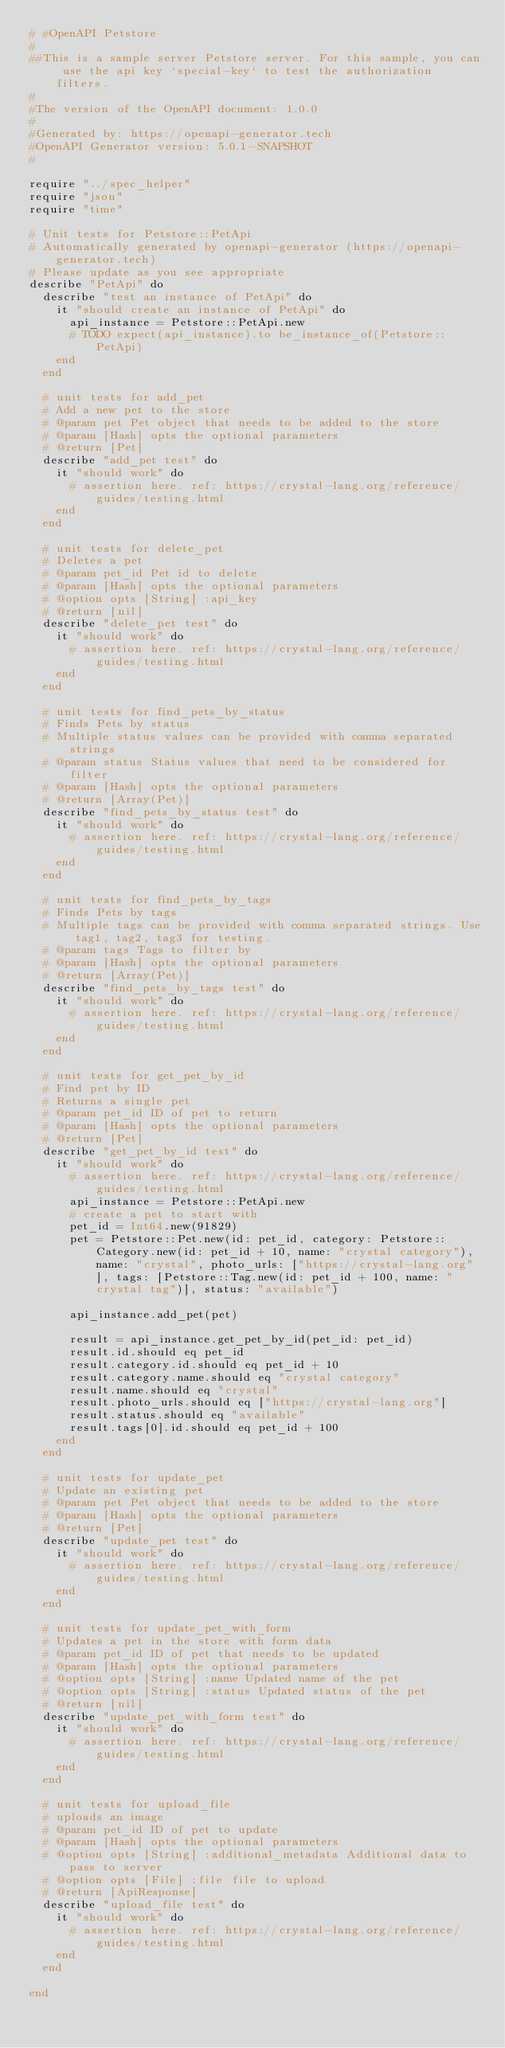Convert code to text. <code><loc_0><loc_0><loc_500><loc_500><_Crystal_># #OpenAPI Petstore
#
##This is a sample server Petstore server. For this sample, you can use the api key `special-key` to test the authorization filters.
#
#The version of the OpenAPI document: 1.0.0
#
#Generated by: https://openapi-generator.tech
#OpenAPI Generator version: 5.0.1-SNAPSHOT
#

require "../spec_helper"
require "json"
require "time"

# Unit tests for Petstore::PetApi
# Automatically generated by openapi-generator (https://openapi-generator.tech)
# Please update as you see appropriate
describe "PetApi" do
  describe "test an instance of PetApi" do
    it "should create an instance of PetApi" do
      api_instance = Petstore::PetApi.new
      # TODO expect(api_instance).to be_instance_of(Petstore::PetApi)
    end
  end

  # unit tests for add_pet
  # Add a new pet to the store
  # @param pet Pet object that needs to be added to the store
  # @param [Hash] opts the optional parameters
  # @return [Pet]
  describe "add_pet test" do
    it "should work" do
      # assertion here. ref: https://crystal-lang.org/reference/guides/testing.html
    end
  end

  # unit tests for delete_pet
  # Deletes a pet
  # @param pet_id Pet id to delete
  # @param [Hash] opts the optional parameters
  # @option opts [String] :api_key 
  # @return [nil]
  describe "delete_pet test" do
    it "should work" do
      # assertion here. ref: https://crystal-lang.org/reference/guides/testing.html
    end
  end

  # unit tests for find_pets_by_status
  # Finds Pets by status
  # Multiple status values can be provided with comma separated strings
  # @param status Status values that need to be considered for filter
  # @param [Hash] opts the optional parameters
  # @return [Array(Pet)]
  describe "find_pets_by_status test" do
    it "should work" do
      # assertion here. ref: https://crystal-lang.org/reference/guides/testing.html
    end
  end

  # unit tests for find_pets_by_tags
  # Finds Pets by tags
  # Multiple tags can be provided with comma separated strings. Use tag1, tag2, tag3 for testing.
  # @param tags Tags to filter by
  # @param [Hash] opts the optional parameters
  # @return [Array(Pet)]
  describe "find_pets_by_tags test" do
    it "should work" do
      # assertion here. ref: https://crystal-lang.org/reference/guides/testing.html
    end
  end

  # unit tests for get_pet_by_id
  # Find pet by ID
  # Returns a single pet
  # @param pet_id ID of pet to return
  # @param [Hash] opts the optional parameters
  # @return [Pet]
  describe "get_pet_by_id test" do
    it "should work" do
      # assertion here. ref: https://crystal-lang.org/reference/guides/testing.html
      api_instance = Petstore::PetApi.new
      # create a pet to start with
      pet_id = Int64.new(91829)
      pet = Petstore::Pet.new(id: pet_id, category: Petstore::Category.new(id: pet_id + 10, name: "crystal category"), name: "crystal", photo_urls: ["https://crystal-lang.org"], tags: [Petstore::Tag.new(id: pet_id + 100, name: "crystal tag")], status: "available")

      api_instance.add_pet(pet)

      result = api_instance.get_pet_by_id(pet_id: pet_id)
      result.id.should eq pet_id
      result.category.id.should eq pet_id + 10
      result.category.name.should eq "crystal category"
      result.name.should eq "crystal"
      result.photo_urls.should eq ["https://crystal-lang.org"]
      result.status.should eq "available" 
      result.tags[0].id.should eq pet_id + 100
    end
  end

  # unit tests for update_pet
  # Update an existing pet
  # @param pet Pet object that needs to be added to the store
  # @param [Hash] opts the optional parameters
  # @return [Pet]
  describe "update_pet test" do
    it "should work" do
      # assertion here. ref: https://crystal-lang.org/reference/guides/testing.html
    end
  end

  # unit tests for update_pet_with_form
  # Updates a pet in the store with form data
  # @param pet_id ID of pet that needs to be updated
  # @param [Hash] opts the optional parameters
  # @option opts [String] :name Updated name of the pet
  # @option opts [String] :status Updated status of the pet
  # @return [nil]
  describe "update_pet_with_form test" do
    it "should work" do
      # assertion here. ref: https://crystal-lang.org/reference/guides/testing.html
    end
  end

  # unit tests for upload_file
  # uploads an image
  # @param pet_id ID of pet to update
  # @param [Hash] opts the optional parameters
  # @option opts [String] :additional_metadata Additional data to pass to server
  # @option opts [File] :file file to upload
  # @return [ApiResponse]
  describe "upload_file test" do
    it "should work" do
      # assertion here. ref: https://crystal-lang.org/reference/guides/testing.html
    end
  end

end
</code> 